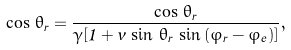<formula> <loc_0><loc_0><loc_500><loc_500>\cos \, \hat { \theta _ { r } } = \frac { \cos \, \theta _ { r } } { \gamma [ 1 + v \, \sin \, \theta _ { r } \, \sin \, ( \varphi _ { r } - \varphi _ { e } ) ] } ,</formula> 